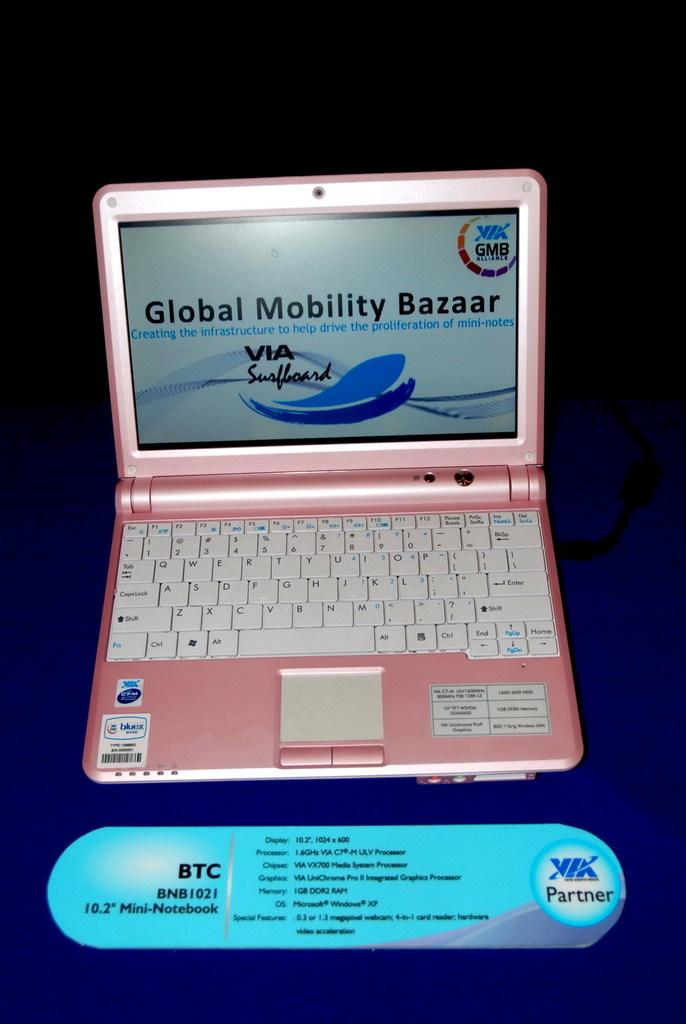<image>
Describe the image concisely. A pink laptop advertises for Global Mobility Bazaar on the display. 